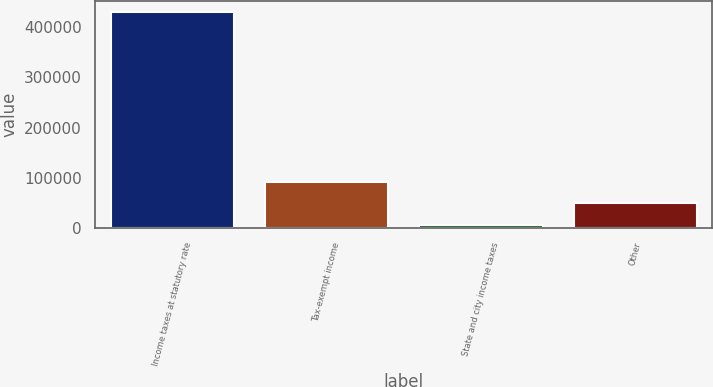Convert chart. <chart><loc_0><loc_0><loc_500><loc_500><bar_chart><fcel>Income taxes at statutory rate<fcel>Tax-exempt income<fcel>State and city income taxes<fcel>Other<nl><fcel>431075<fcel>91311.8<fcel>6371<fcel>48841.4<nl></chart> 